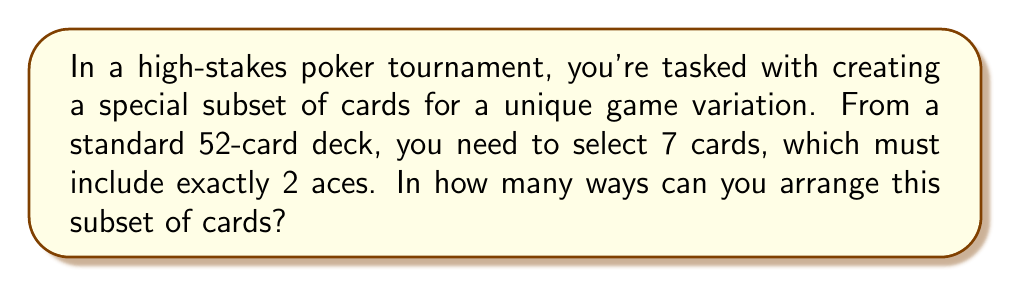Solve this math problem. Let's break this down step-by-step:

1) First, we need to select 2 aces from the 4 aces in a standard deck:
   $$\binom{4}{2} = \frac{4!}{2!(4-2)!} = 6$$ ways

2) Then, we need to select 5 more cards from the remaining 48 cards (52 - 4 aces):
   $$\binom{48}{5} = \frac{48!}{5!(48-5)!} = 1,712,304$$ ways

3) Now, we have our subset of 7 cards. The question asks for the number of ways to arrange this subset. This is a straightforward permutation of 7 items:
   $$P(7,7) = 7! = 5,040$$ ways

4) By the multiplication principle, the total number of ways to select and arrange this subset is:
   $$6 \times 1,712,304 \times 5,040 = 51,877,612,800$$

Therefore, there are 51,877,612,800 ways to arrange this subset of cards.
Answer: 51,877,612,800 